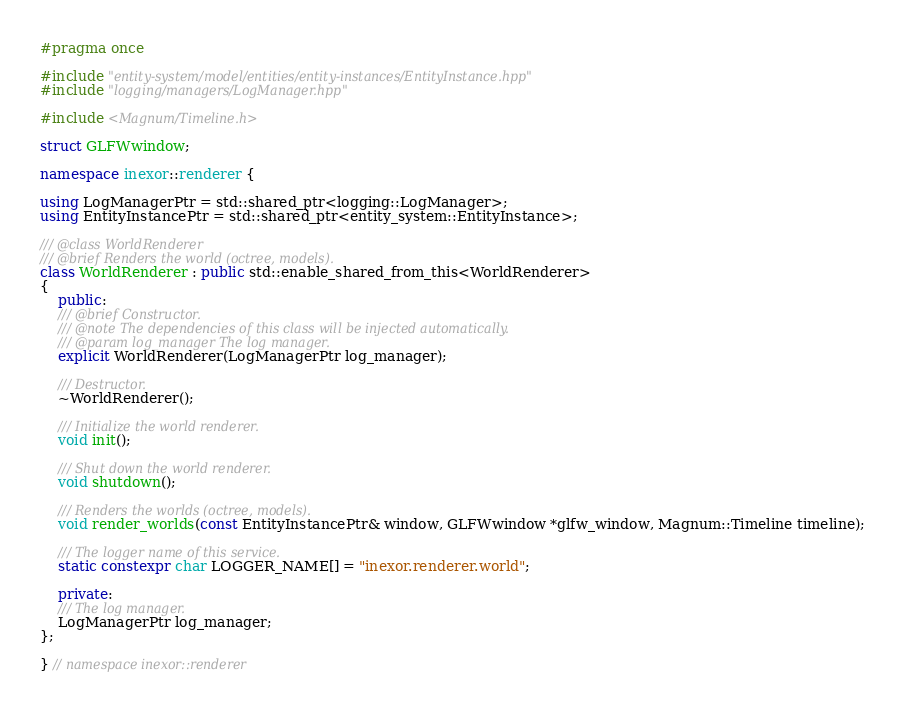Convert code to text. <code><loc_0><loc_0><loc_500><loc_500><_C++_>#pragma once

#include "entity-system/model/entities/entity-instances/EntityInstance.hpp"
#include "logging/managers/LogManager.hpp"

#include <Magnum/Timeline.h>

struct GLFWwindow;

namespace inexor::renderer {

using LogManagerPtr = std::shared_ptr<logging::LogManager>;
using EntityInstancePtr = std::shared_ptr<entity_system::EntityInstance>;

/// @class WorldRenderer
/// @brief Renders the world (octree, models).
class WorldRenderer : public std::enable_shared_from_this<WorldRenderer>
{
    public:
    /// @brief Constructor.
    /// @note The dependencies of this class will be injected automatically.
    /// @param log_manager The log manager.
    explicit WorldRenderer(LogManagerPtr log_manager);

    /// Destructor.
    ~WorldRenderer();

    /// Initialize the world renderer.
    void init();

    /// Shut down the world renderer.
    void shutdown();

    /// Renders the worlds (octree, models).
    void render_worlds(const EntityInstancePtr& window, GLFWwindow *glfw_window, Magnum::Timeline timeline);

    /// The logger name of this service.
    static constexpr char LOGGER_NAME[] = "inexor.renderer.world";

    private:
    /// The log manager.
    LogManagerPtr log_manager;
};

} // namespace inexor::renderer
</code> 